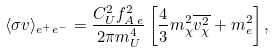<formula> <loc_0><loc_0><loc_500><loc_500>\langle \sigma v \rangle _ { e ^ { + } e ^ { - } } = \frac { C _ { U } ^ { 2 } f _ { A \, e } ^ { 2 } } { 2 \pi m _ { U } ^ { 4 } } \left [ \frac { 4 } { 3 } m _ { \chi } ^ { 2 } \overline { v _ { \chi } ^ { 2 } } + m _ { e } ^ { 2 } \right ] ,</formula> 